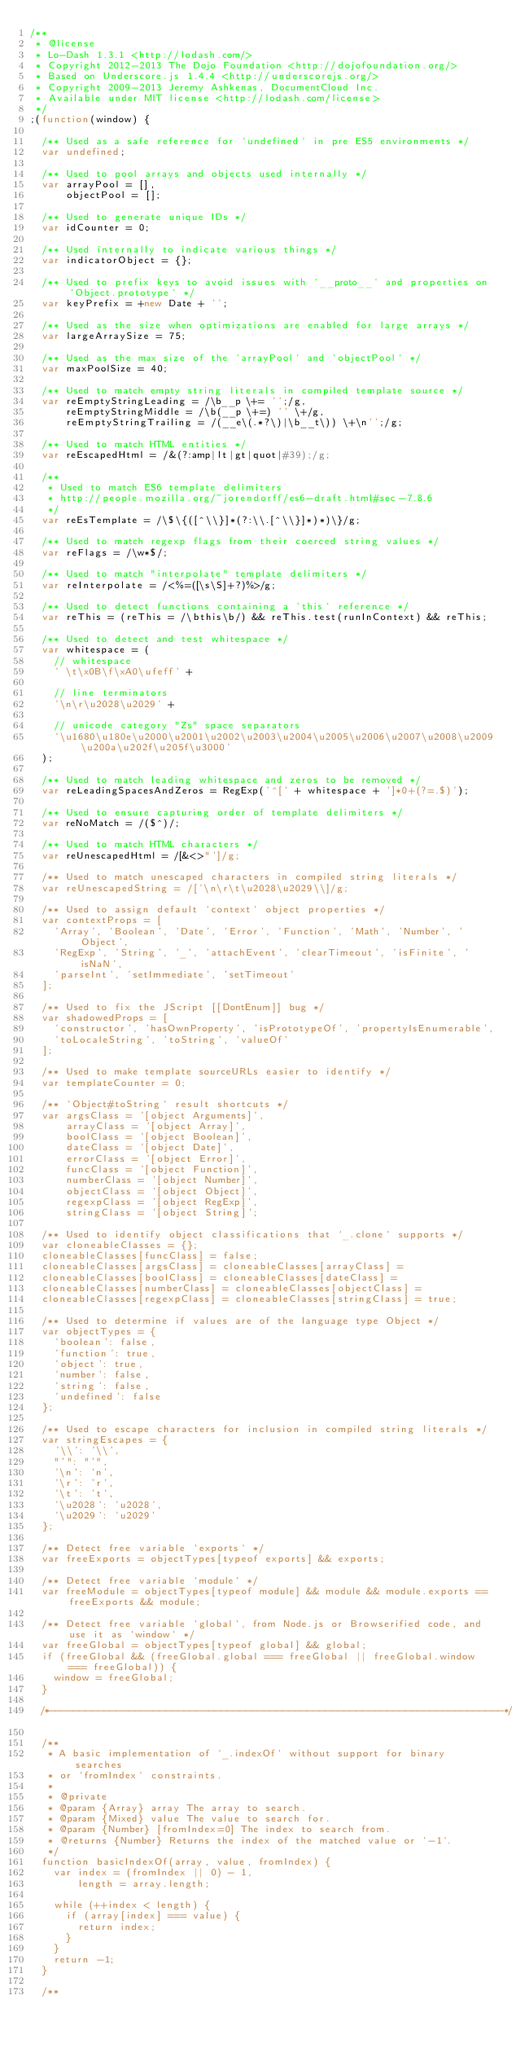Convert code to text. <code><loc_0><loc_0><loc_500><loc_500><_JavaScript_>/**
 * @license
 * Lo-Dash 1.3.1 <http://lodash.com/>
 * Copyright 2012-2013 The Dojo Foundation <http://dojofoundation.org/>
 * Based on Underscore.js 1.4.4 <http://underscorejs.org/>
 * Copyright 2009-2013 Jeremy Ashkenas, DocumentCloud Inc.
 * Available under MIT license <http://lodash.com/license>
 */
;(function(window) {

  /** Used as a safe reference for `undefined` in pre ES5 environments */
  var undefined;

  /** Used to pool arrays and objects used internally */
  var arrayPool = [],
      objectPool = [];

  /** Used to generate unique IDs */
  var idCounter = 0;

  /** Used internally to indicate various things */
  var indicatorObject = {};

  /** Used to prefix keys to avoid issues with `__proto__` and properties on `Object.prototype` */
  var keyPrefix = +new Date + '';

  /** Used as the size when optimizations are enabled for large arrays */
  var largeArraySize = 75;

  /** Used as the max size of the `arrayPool` and `objectPool` */
  var maxPoolSize = 40;

  /** Used to match empty string literals in compiled template source */
  var reEmptyStringLeading = /\b__p \+= '';/g,
      reEmptyStringMiddle = /\b(__p \+=) '' \+/g,
      reEmptyStringTrailing = /(__e\(.*?\)|\b__t\)) \+\n'';/g;

  /** Used to match HTML entities */
  var reEscapedHtml = /&(?:amp|lt|gt|quot|#39);/g;

  /**
   * Used to match ES6 template delimiters
   * http://people.mozilla.org/~jorendorff/es6-draft.html#sec-7.8.6
   */
  var reEsTemplate = /\$\{([^\\}]*(?:\\.[^\\}]*)*)\}/g;

  /** Used to match regexp flags from their coerced string values */
  var reFlags = /\w*$/;

  /** Used to match "interpolate" template delimiters */
  var reInterpolate = /<%=([\s\S]+?)%>/g;

  /** Used to detect functions containing a `this` reference */
  var reThis = (reThis = /\bthis\b/) && reThis.test(runInContext) && reThis;

  /** Used to detect and test whitespace */
  var whitespace = (
    // whitespace
    ' \t\x0B\f\xA0\ufeff' +

    // line terminators
    '\n\r\u2028\u2029' +

    // unicode category "Zs" space separators
    '\u1680\u180e\u2000\u2001\u2002\u2003\u2004\u2005\u2006\u2007\u2008\u2009\u200a\u202f\u205f\u3000'
  );

  /** Used to match leading whitespace and zeros to be removed */
  var reLeadingSpacesAndZeros = RegExp('^[' + whitespace + ']*0+(?=.$)');

  /** Used to ensure capturing order of template delimiters */
  var reNoMatch = /($^)/;

  /** Used to match HTML characters */
  var reUnescapedHtml = /[&<>"']/g;

  /** Used to match unescaped characters in compiled string literals */
  var reUnescapedString = /['\n\r\t\u2028\u2029\\]/g;

  /** Used to assign default `context` object properties */
  var contextProps = [
    'Array', 'Boolean', 'Date', 'Error', 'Function', 'Math', 'Number', 'Object',
    'RegExp', 'String', '_', 'attachEvent', 'clearTimeout', 'isFinite', 'isNaN',
    'parseInt', 'setImmediate', 'setTimeout'
  ];

  /** Used to fix the JScript [[DontEnum]] bug */
  var shadowedProps = [
    'constructor', 'hasOwnProperty', 'isPrototypeOf', 'propertyIsEnumerable',
    'toLocaleString', 'toString', 'valueOf'
  ];

  /** Used to make template sourceURLs easier to identify */
  var templateCounter = 0;

  /** `Object#toString` result shortcuts */
  var argsClass = '[object Arguments]',
      arrayClass = '[object Array]',
      boolClass = '[object Boolean]',
      dateClass = '[object Date]',
      errorClass = '[object Error]',
      funcClass = '[object Function]',
      numberClass = '[object Number]',
      objectClass = '[object Object]',
      regexpClass = '[object RegExp]',
      stringClass = '[object String]';

  /** Used to identify object classifications that `_.clone` supports */
  var cloneableClasses = {};
  cloneableClasses[funcClass] = false;
  cloneableClasses[argsClass] = cloneableClasses[arrayClass] =
  cloneableClasses[boolClass] = cloneableClasses[dateClass] =
  cloneableClasses[numberClass] = cloneableClasses[objectClass] =
  cloneableClasses[regexpClass] = cloneableClasses[stringClass] = true;

  /** Used to determine if values are of the language type Object */
  var objectTypes = {
    'boolean': false,
    'function': true,
    'object': true,
    'number': false,
    'string': false,
    'undefined': false
  };

  /** Used to escape characters for inclusion in compiled string literals */
  var stringEscapes = {
    '\\': '\\',
    "'": "'",
    '\n': 'n',
    '\r': 'r',
    '\t': 't',
    '\u2028': 'u2028',
    '\u2029': 'u2029'
  };

  /** Detect free variable `exports` */
  var freeExports = objectTypes[typeof exports] && exports;

  /** Detect free variable `module` */
  var freeModule = objectTypes[typeof module] && module && module.exports == freeExports && module;

  /** Detect free variable `global`, from Node.js or Browserified code, and use it as `window` */
  var freeGlobal = objectTypes[typeof global] && global;
  if (freeGlobal && (freeGlobal.global === freeGlobal || freeGlobal.window === freeGlobal)) {
    window = freeGlobal;
  }

  /*--------------------------------------------------------------------------*/

  /**
   * A basic implementation of `_.indexOf` without support for binary searches
   * or `fromIndex` constraints.
   *
   * @private
   * @param {Array} array The array to search.
   * @param {Mixed} value The value to search for.
   * @param {Number} [fromIndex=0] The index to search from.
   * @returns {Number} Returns the index of the matched value or `-1`.
   */
  function basicIndexOf(array, value, fromIndex) {
    var index = (fromIndex || 0) - 1,
        length = array.length;

    while (++index < length) {
      if (array[index] === value) {
        return index;
      }
    }
    return -1;
  }

  /**</code> 